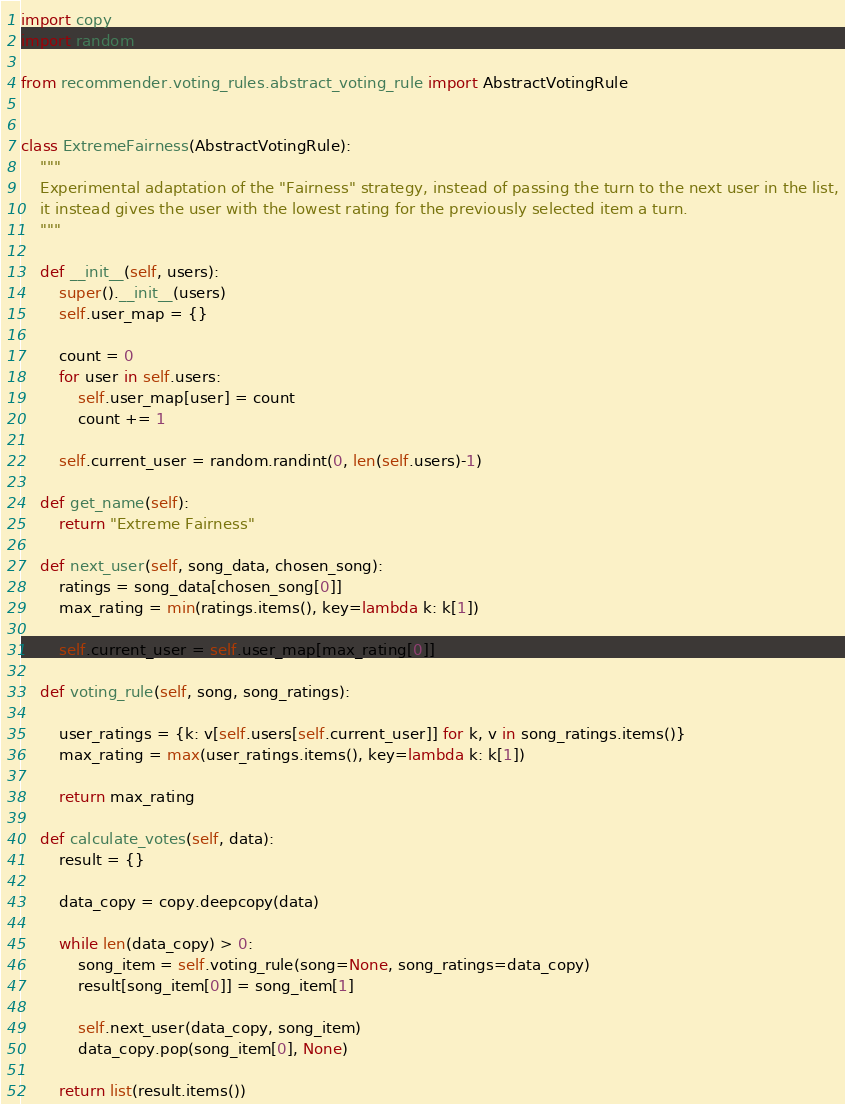Convert code to text. <code><loc_0><loc_0><loc_500><loc_500><_Python_>import copy
import random

from recommender.voting_rules.abstract_voting_rule import AbstractVotingRule


class ExtremeFairness(AbstractVotingRule):
    """
    Experimental adaptation of the "Fairness" strategy, instead of passing the turn to the next user in the list,
    it instead gives the user with the lowest rating for the previously selected item a turn.
    """

    def __init__(self, users):
        super().__init__(users)
        self.user_map = {}

        count = 0
        for user in self.users:
            self.user_map[user] = count
            count += 1

        self.current_user = random.randint(0, len(self.users)-1)

    def get_name(self):
        return "Extreme Fairness"

    def next_user(self, song_data, chosen_song):
        ratings = song_data[chosen_song[0]]
        max_rating = min(ratings.items(), key=lambda k: k[1])

        self.current_user = self.user_map[max_rating[0]]

    def voting_rule(self, song, song_ratings):

        user_ratings = {k: v[self.users[self.current_user]] for k, v in song_ratings.items()}
        max_rating = max(user_ratings.items(), key=lambda k: k[1])

        return max_rating

    def calculate_votes(self, data):
        result = {}

        data_copy = copy.deepcopy(data)

        while len(data_copy) > 0:
            song_item = self.voting_rule(song=None, song_ratings=data_copy)
            result[song_item[0]] = song_item[1]

            self.next_user(data_copy, song_item)
            data_copy.pop(song_item[0], None)

        return list(result.items())
</code> 